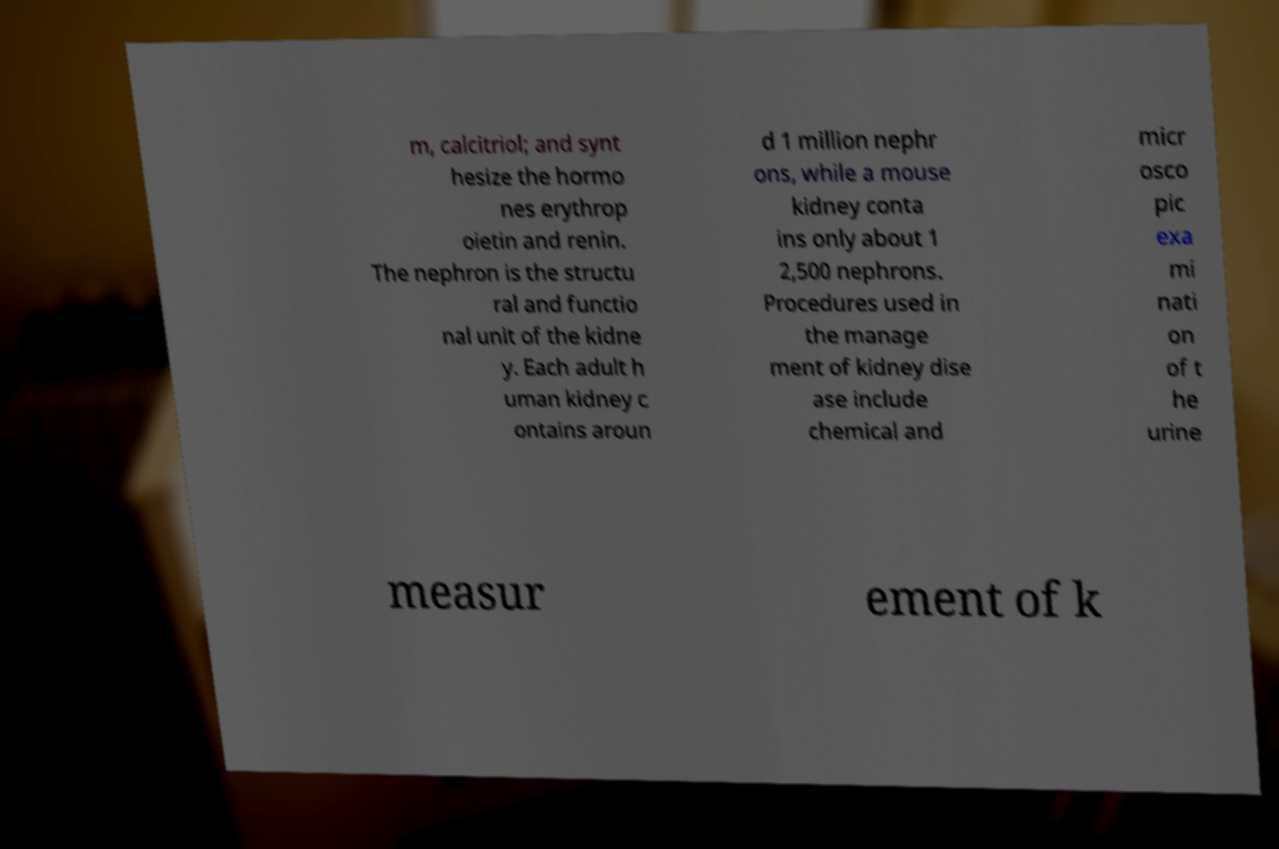What messages or text are displayed in this image? I need them in a readable, typed format. m, calcitriol; and synt hesize the hormo nes erythrop oietin and renin. The nephron is the structu ral and functio nal unit of the kidne y. Each adult h uman kidney c ontains aroun d 1 million nephr ons, while a mouse kidney conta ins only about 1 2,500 nephrons. Procedures used in the manage ment of kidney dise ase include chemical and micr osco pic exa mi nati on of t he urine measur ement of k 